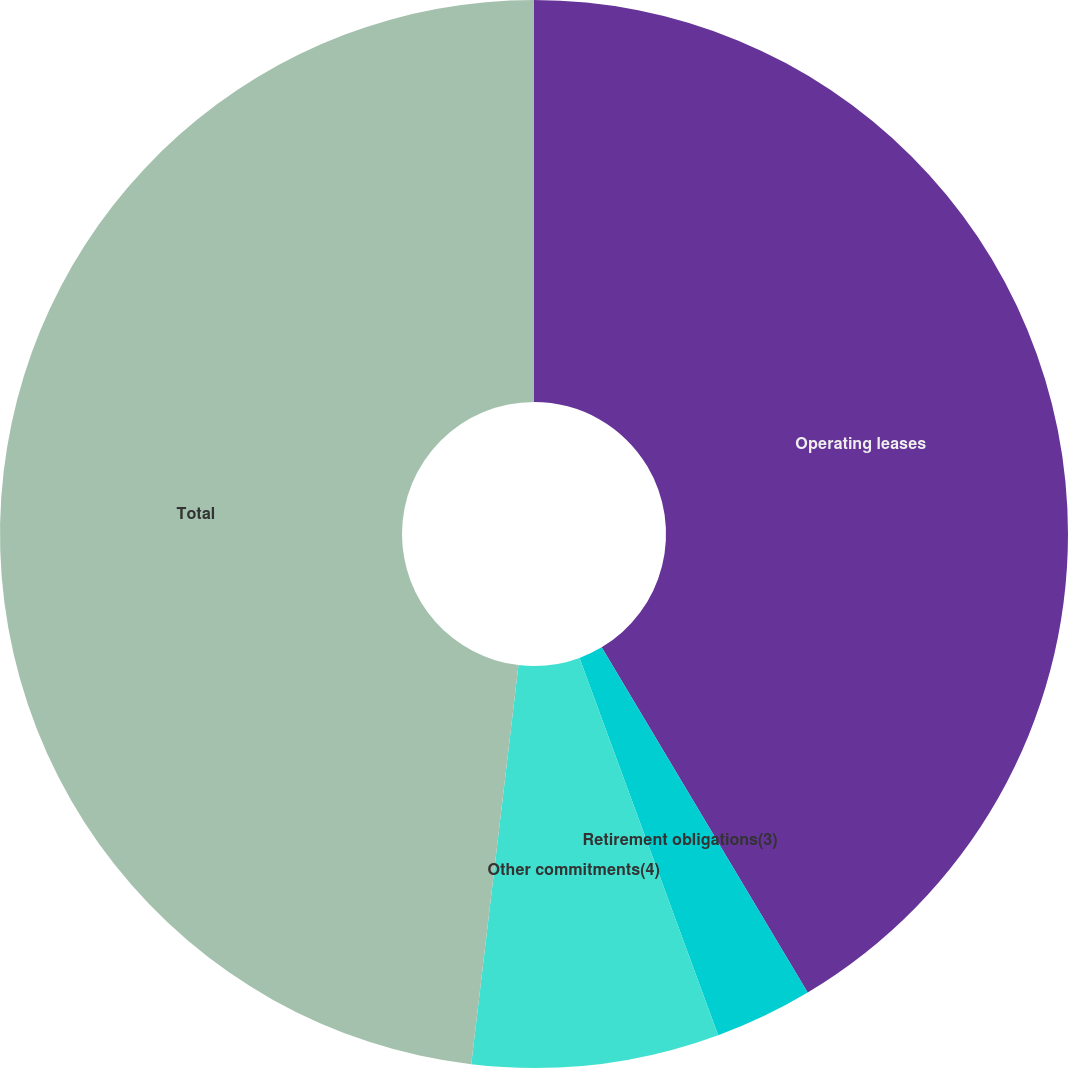Convert chart to OTSL. <chart><loc_0><loc_0><loc_500><loc_500><pie_chart><fcel>Operating leases<fcel>Retirement obligations(3)<fcel>Other commitments(4)<fcel>Total<nl><fcel>41.44%<fcel>2.96%<fcel>7.48%<fcel>48.13%<nl></chart> 